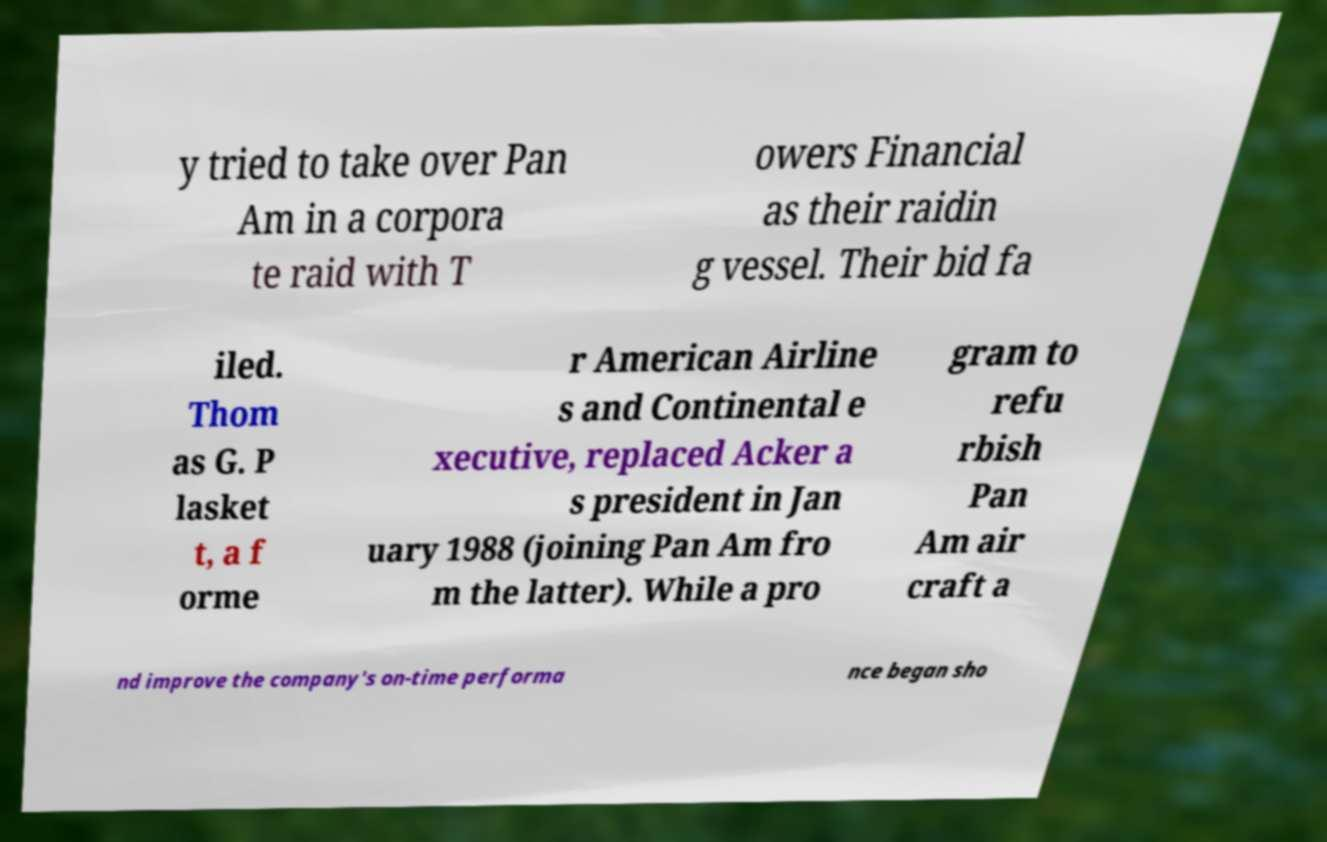What messages or text are displayed in this image? I need them in a readable, typed format. y tried to take over Pan Am in a corpora te raid with T owers Financial as their raidin g vessel. Their bid fa iled. Thom as G. P lasket t, a f orme r American Airline s and Continental e xecutive, replaced Acker a s president in Jan uary 1988 (joining Pan Am fro m the latter). While a pro gram to refu rbish Pan Am air craft a nd improve the company's on-time performa nce began sho 